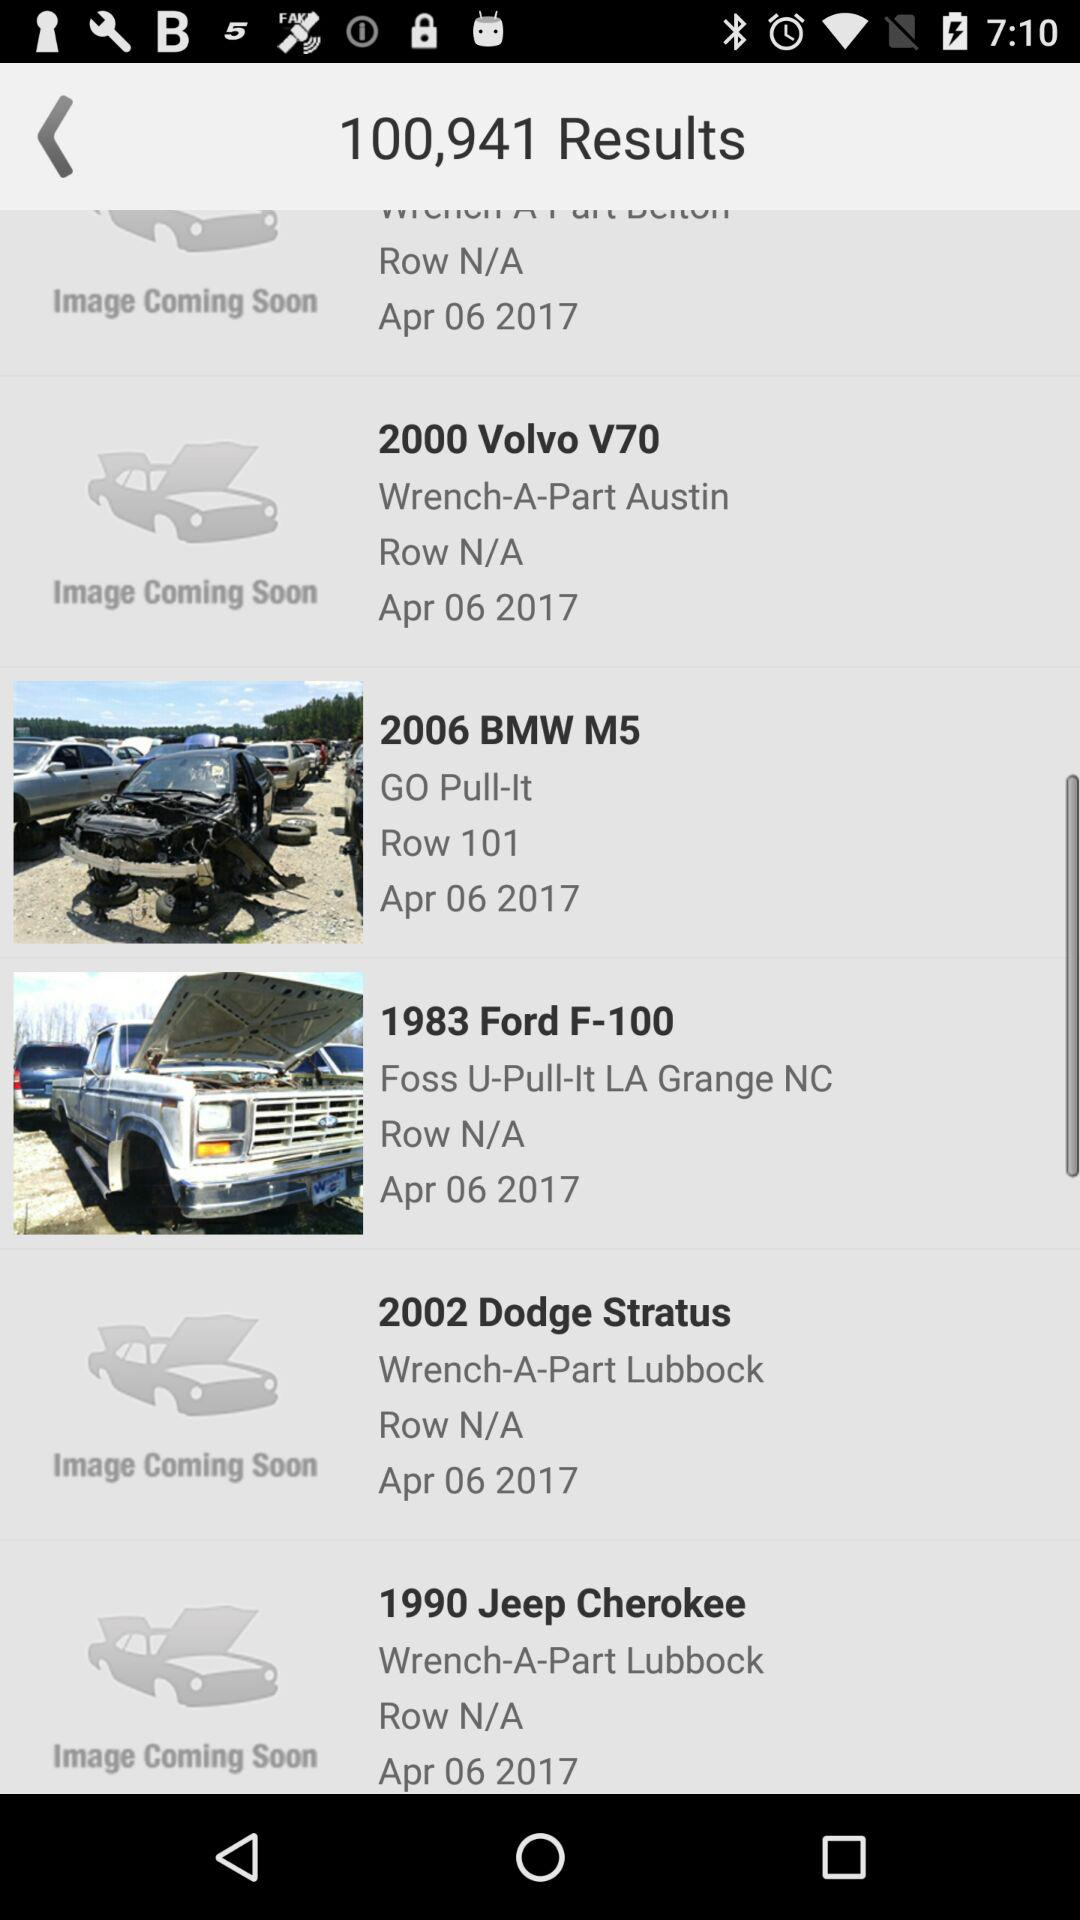What is the publication date of the 1983 Ford F-100? The publication date of the 1983 Ford F-100 is April 6, 2017. 